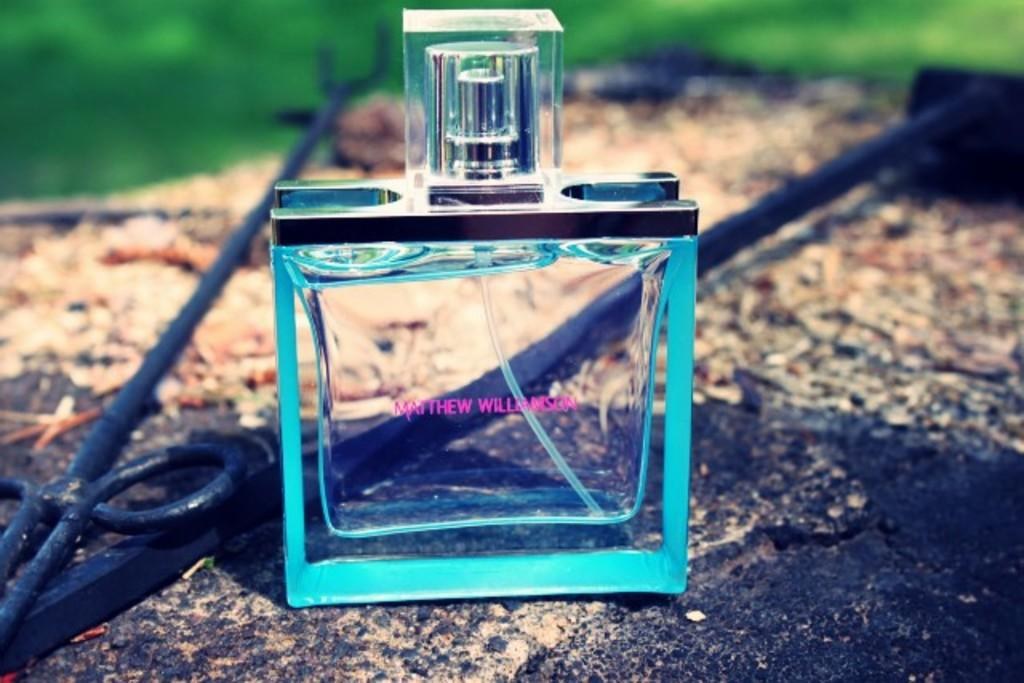Provide a one-sentence caption for the provided image. A blue bottle of cologne made by Matthew Williamson sitting on a rock. 